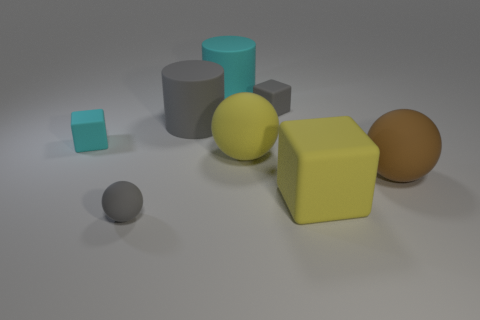Add 1 large gray cylinders. How many objects exist? 9 Subtract all spheres. How many objects are left? 5 Add 1 big blue objects. How many big blue objects exist? 1 Subtract 0 green balls. How many objects are left? 8 Subtract all brown objects. Subtract all large purple shiny objects. How many objects are left? 7 Add 4 brown matte things. How many brown matte things are left? 5 